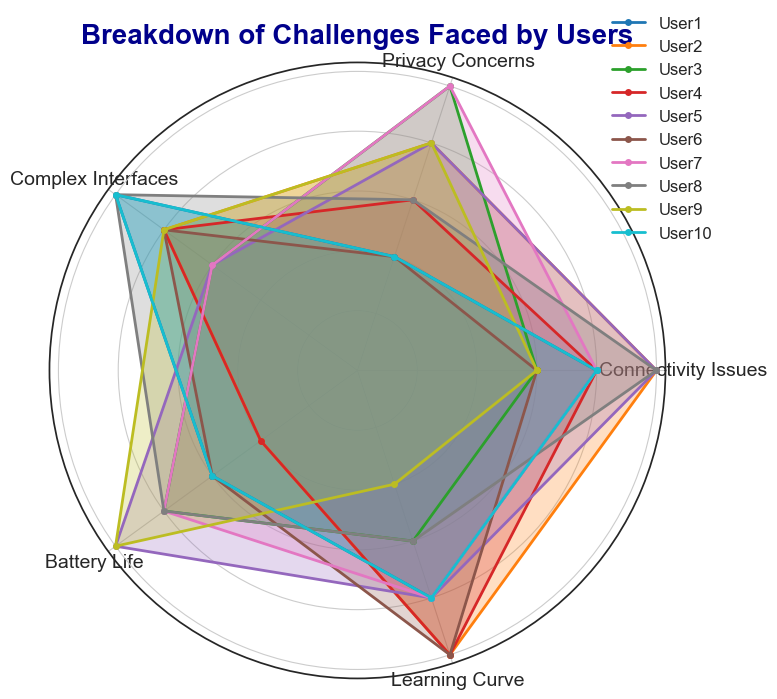How many users rated Connectivity Issues higher than Privacy Concerns? By observing the Connectivity Issues and Privacy Concerns scores for each user, we can see that Users 1, 5, 6, 8, and 10 rated Connectivity Issues higher than Privacy Concerns.
Answer: 5 Which category has the least variability in user ratings? The least variability in user ratings can be assessed by observing the spread of values in each category. Learning Curve has ratings mostly centered around 4 and 5 with a consistent pattern, indicating less variability.
Answer: Learning Curve Between Connectivity Issues and Battery Life, which challenge has a higher average rating? To find the average rating, sum the scores for each challenge and divide by the number of users. The average for Connectivity Issues = (4+5+3+4+5+3+4+5+3+4)/10 = 4. The average for Battery Life = (3+2+4+2+5+3+4+4+5+3)/10 = 3.5. Therefore, Connectivity Issues has a higher average rating.
Answer: Connectivity Issues Which user(s) rated Privacy Concerns higher than Battery Life? By comparing the Privacy Concerns and Battery Life scores for each user, we find that Users 2, 3, 7, 9 rated Privacy Concerns higher than Battery Life.
Answer: Users 2, 3, 7, 9 What is the median rating for Complex Interfaces among all users? Sort the Complex Interfaces scores: [3, 3, 3, 3, 4, 4, 4, 4, 5, 5]. Since there are 10 values, the median will be the average of the 5th and 6th values. So, (4+4)/2 = 4.
Answer: 4 Which category has the highest maximum rating? By observing the highest possible rating in each category, all challenges except Learning Curve have a maximum score of 5. The highest score in Learning Curve is 5 as well.
Answer: Connectivity Issues, Privacy Concerns, Complex Interfaces, Battery Life, Learning Curve Which user experienced the least difficulty overall based on their ratings? The least difficulty can be interpreted as the lowest sum of ratings across all categories. Calculate the sum for each user: User1 = 18, User2 = 20, User3 = 18, User4 = 18, User5 = 21, User6 = 17, User7 = 20, User8 = 20, User9 = 18, User10 = 18. User 6 has the lowest total score of 17.
Answer: User 6 How many users gave a rating of 5 for Complex Interfaces? By observing the Complex Interfaces scores, ratings of 5 were given by User1, User8, and User10.
Answer: 3 Which category received the most consistent ratings of 4 across all users? Observe the number of 4's in each category: Connectivity Issues (4), Privacy Concerns (1), Complex Interfaces (4), Battery Life (3), Learning Curve (4). Three categories (Connectivity Issues, Complex Interfaces and Learning Curve) have the most consistent ratings of 4.
Answer: Connectivity Issues, Complex Interfaces, Learning Curve 